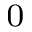Convert formula to latex. <formula><loc_0><loc_0><loc_500><loc_500>_ { 0 }</formula> 